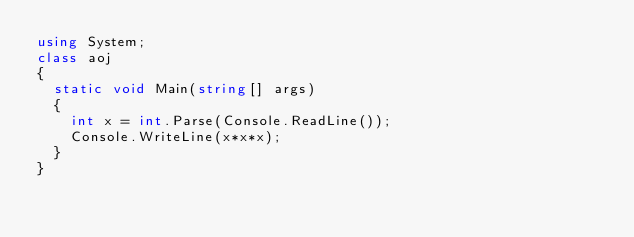Convert code to text. <code><loc_0><loc_0><loc_500><loc_500><_C#_>using System;
class aoj
{
	static void Main(string[] args)
	{
		int x = int.Parse(Console.ReadLine());
		Console.WriteLine(x*x*x);
	}
}</code> 